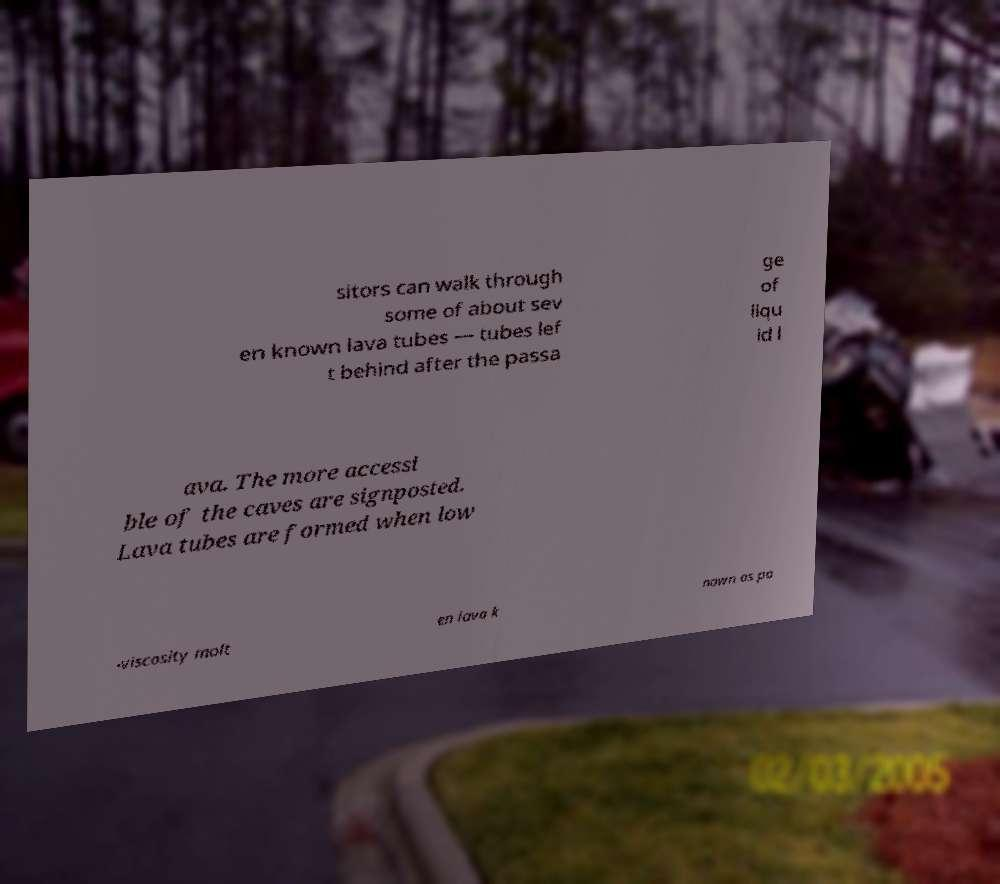Can you accurately transcribe the text from the provided image for me? sitors can walk through some of about sev en known lava tubes — tubes lef t behind after the passa ge of liqu id l ava. The more accessi ble of the caves are signposted. Lava tubes are formed when low -viscosity molt en lava k nown as pa 